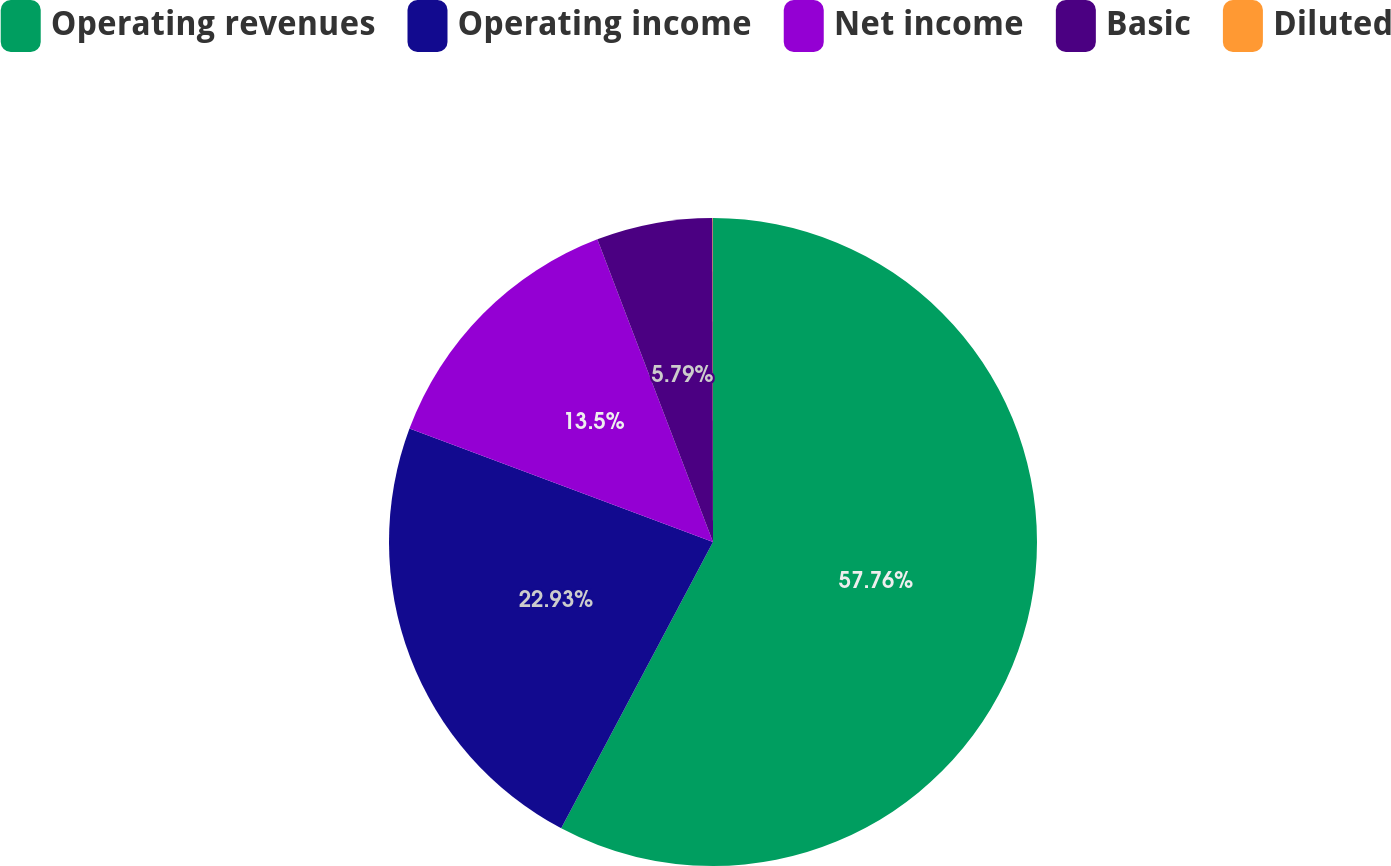Convert chart. <chart><loc_0><loc_0><loc_500><loc_500><pie_chart><fcel>Operating revenues<fcel>Operating income<fcel>Net income<fcel>Basic<fcel>Diluted<nl><fcel>57.76%<fcel>22.93%<fcel>13.5%<fcel>5.79%<fcel>0.02%<nl></chart> 